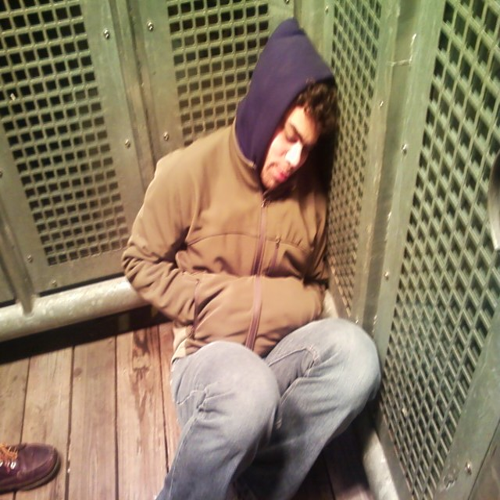Is this a secure location for someone to sleep? From what we can see, the person is in a semi-enclosed space with metal grating, which suggests a degree of separation from a public area. However, regardless of perceived security, sleeping in a public or semi-public location generally carries risks, and it's not advisable without proper precautions. 